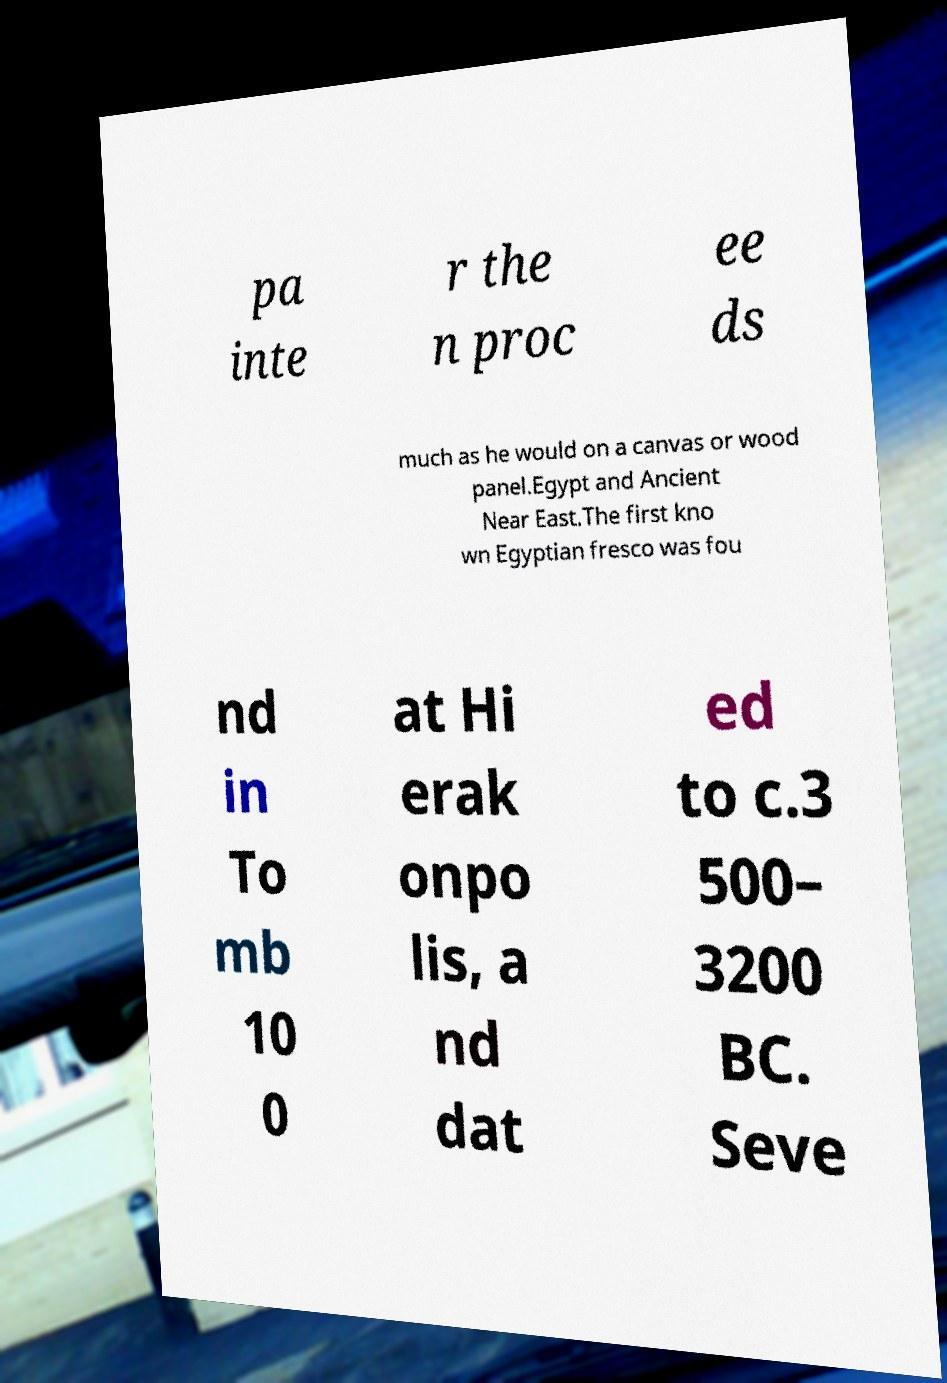For documentation purposes, I need the text within this image transcribed. Could you provide that? pa inte r the n proc ee ds much as he would on a canvas or wood panel.Egypt and Ancient Near East.The first kno wn Egyptian fresco was fou nd in To mb 10 0 at Hi erak onpo lis, a nd dat ed to c.3 500– 3200 BC. Seve 